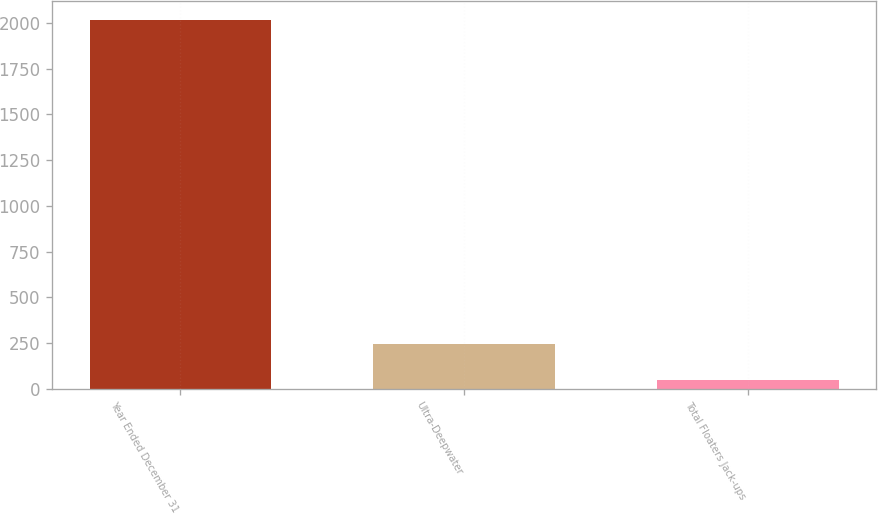<chart> <loc_0><loc_0><loc_500><loc_500><bar_chart><fcel>Year Ended December 31<fcel>Ultra-Deepwater<fcel>Total Floaters Jack-ups<nl><fcel>2016<fcel>242.1<fcel>45<nl></chart> 